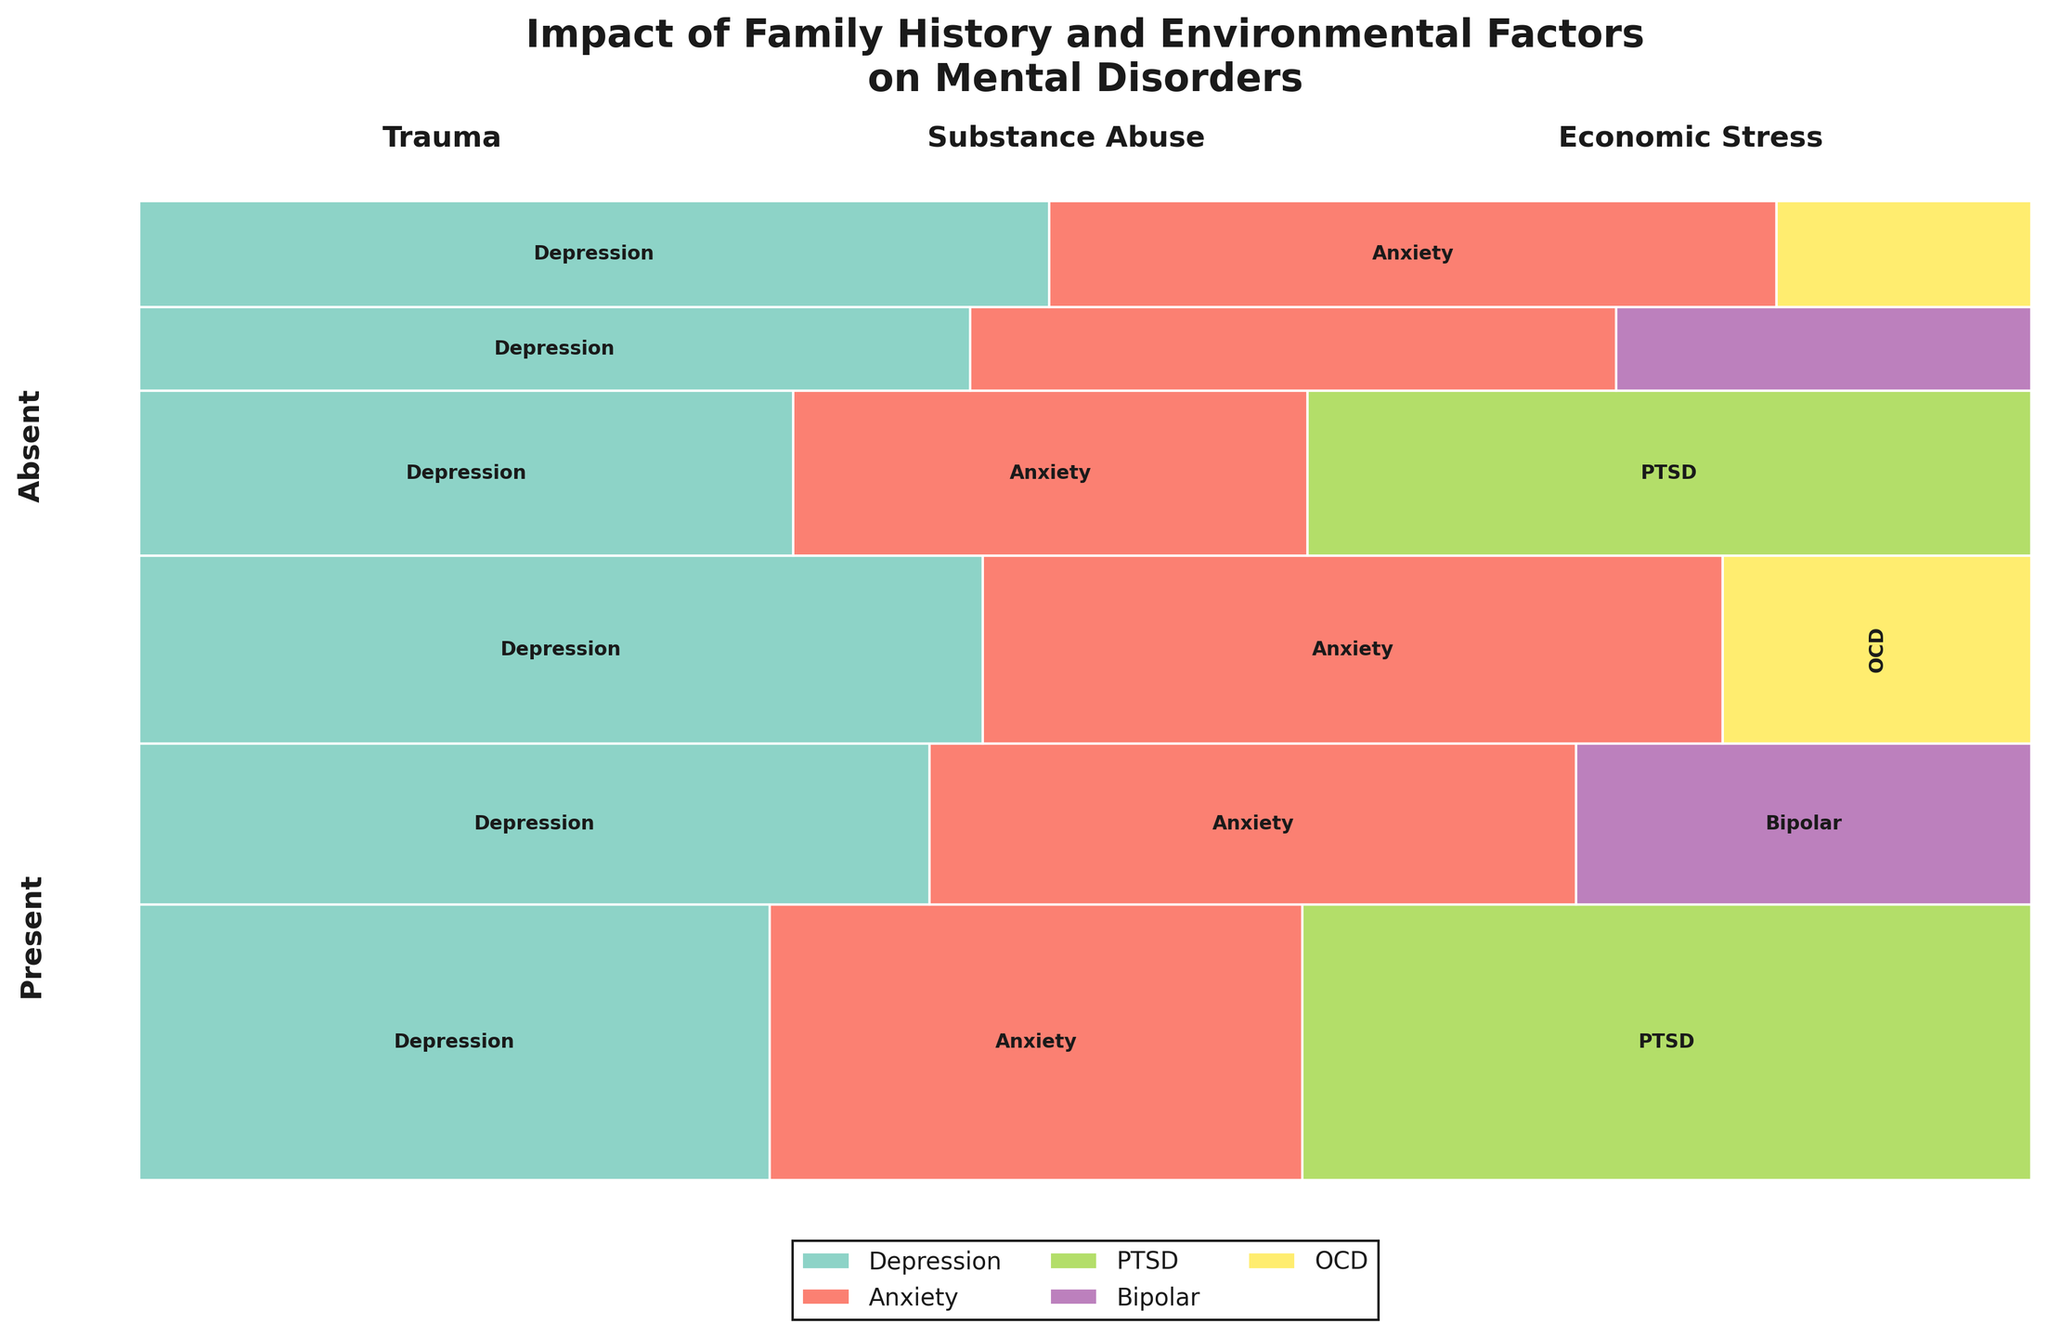What is the title of the plot? The title is displayed at the top of the figure, clearly stating the focus of the plot.
Answer: Impact of Family History and Environmental Factors on Mental Disorders Which mental disorder has the largest segment within the 'Present' family history and 'Trauma' environmental factor? Look at the 'Present' family history and 'Trauma' environmental factor sections' tallest and widest segments. The largest segment is 'PTSD'.
Answer: PTSD What colors are used to represent the different mental disorders in the plot? The different mental disorders are represented by distinct colors, which can be cross-referenced with the legend at the bottom of the plot.
Answer: Set3 colormap Which environmental factor has the highest combined occurrence of mental disorders for individuals with a 'Present' family history? Sum the heights of all rectangles in each environmental factor category under 'Present' family history. The 'Trauma' category has the largest combined height.
Answer: Trauma Which environmental factor shows the lowest occurrence of 'Bipolar' disorder for individuals with a 'Present' family history? Identify the segment labeled 'Bipolar' within the 'Present' family history sections and compare their sizes. The smallest segment is in the 'Substance Abuse' category.
Answer: Substance Abuse How does the occurrence of 'Anxiety' compare between 'Present' and 'Absent' family histories under the 'Economic Stress' factor? Compare the segments labeled 'Anxiety' under 'Economic Stress' for both family histories. The segment is larger in the 'Present' family history.
Answer: Higher in Present What is the combined occurrence of 'PTSD' in individuals with 'Trauma' history, regardless of family history? Add the sizes of 'PTSD' segments in 'Trauma' for both 'Present' and 'Absent' family histories. The combined occurrence is the sum of these two components.
Answer: Higher for 'Present' Which mental disorder is least affected by 'Substance Abuse' for individuals with 'Absent' family history? Identify the smallest rectangle under 'Substance Abuse' for 'Absent' family history. The smallest segment represents 'Bipolar'.
Answer: Bipolar Between 'Economic Stress' and 'Trauma', which has a higher occurrence of 'Depression' for individuals with 'Absent' family history? Compare the sizes of the 'Depression' segments under 'Economic Stress' and 'Trauma' for 'Absent' family history. 'Economic Stress' has a taller segment.
Answer: Economic Stress What is the most common mental disorder for individuals with a 'Present' family history? Across all environmental factors under 'Present' family history, identify the disorder with the largest aggregate segment size. This can be observed by summing the heights of corresponding segments.
Answer: Depression 